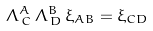Convert formula to latex. <formula><loc_0><loc_0><loc_500><loc_500>\Lambda ^ { A } _ { \, C } \, \Lambda ^ { B } _ { \, D } \, \xi _ { A B } = \xi _ { C D }</formula> 